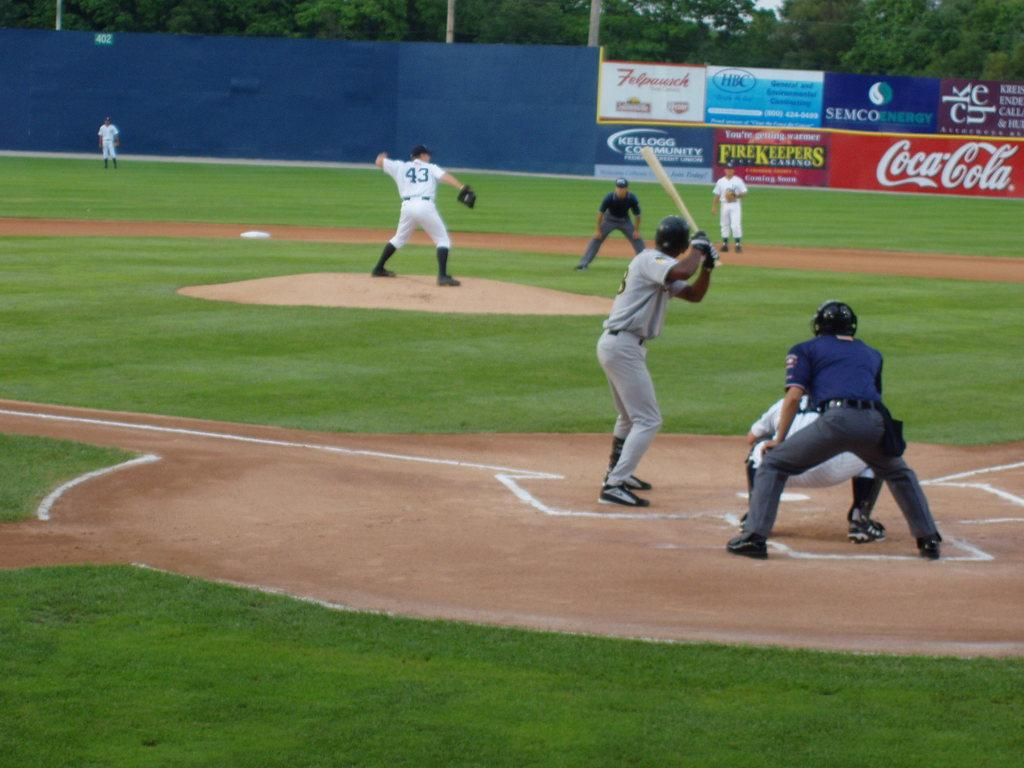<image>
Relay a brief, clear account of the picture shown. A baseball player in a white uniform and the number 43 on his back is about to throw a ball. 